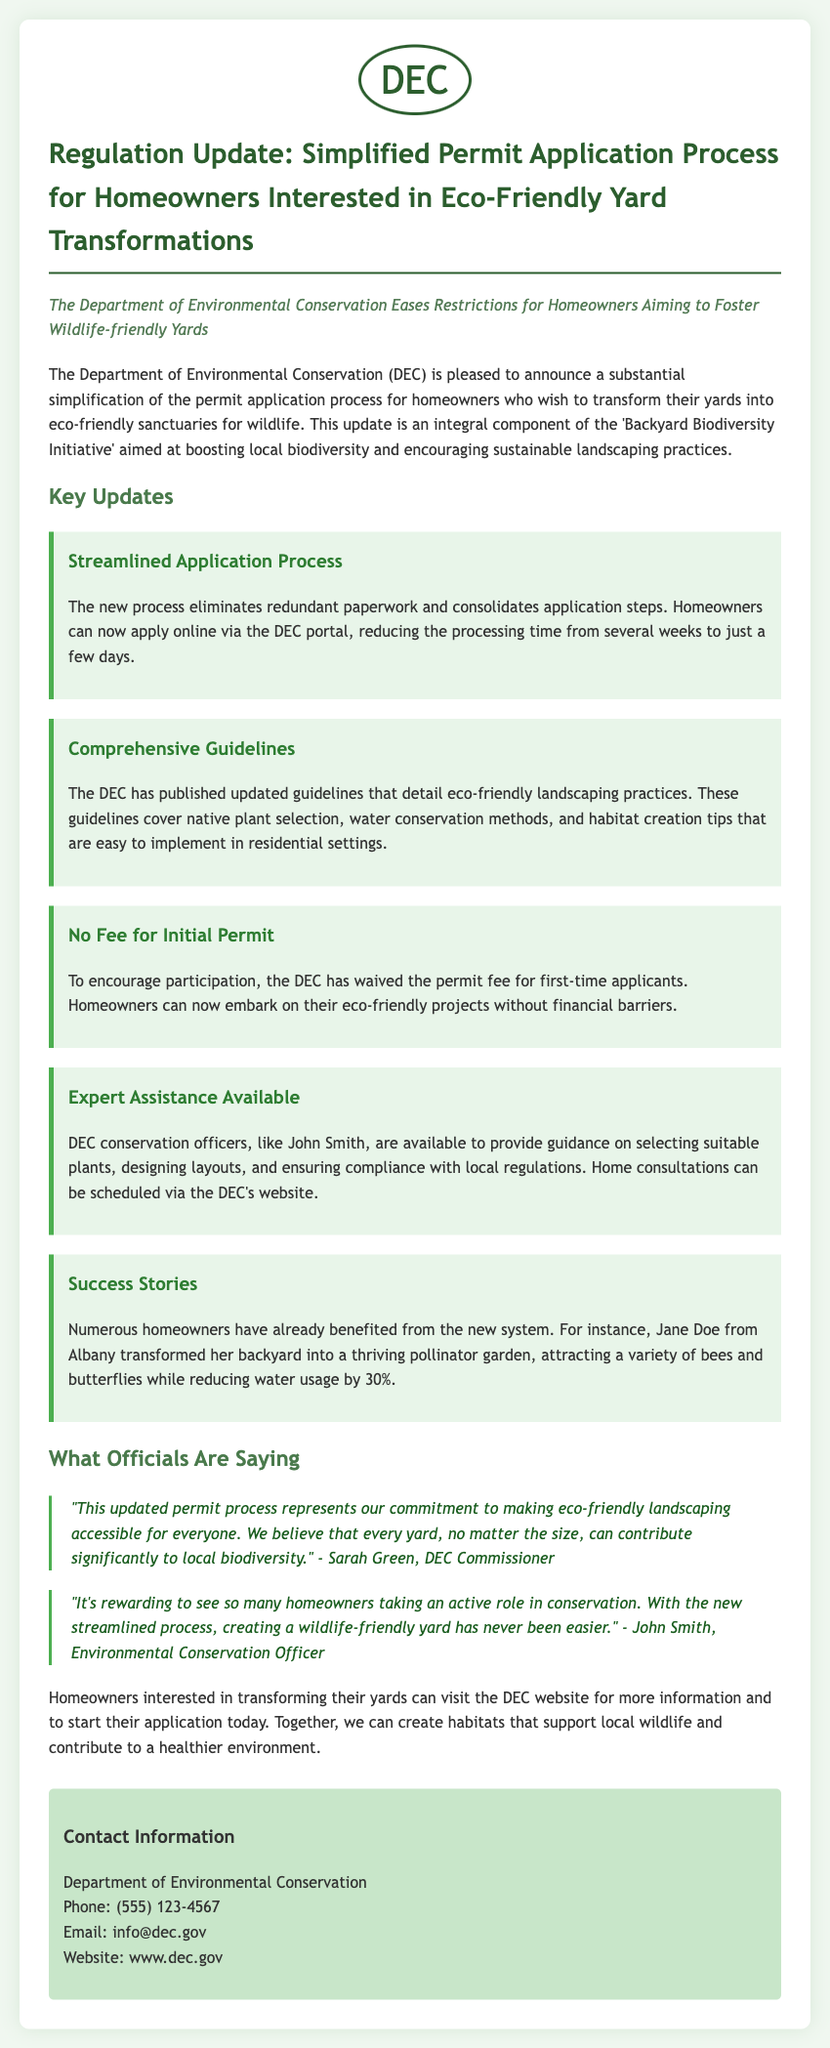What is the title of the press release? The title is the main heading that conveys the primary message of the document.
Answer: Regulation Update: Simplified Permit Application Process for Homeowners Interested in Eco-Friendly Yard Transformations Who published the updated guidelines? The updated guidelines were released by an organization tasked with environmental conservation.
Answer: DEC What initiative is mentioned in the press release? The initiative focuses on promoting biodiversity through easier processes for homeowners.
Answer: Backyard Biodiversity Initiative What is the new processing time for permit applications? The processing time is a key aspect of the updated application process, which was previously longer.
Answer: a few days How much is the permit fee for first-time applicants? The fee amount has been changed to encourage participation among new applicants.
Answer: No Fee Who can provide guidance to homeowners on landscaping? The role of guidance is essential for homeowners looking to comply with new regulations.
Answer: DEC conservation officers What type of garden did Jane Doe create? The example of Jane Doe highlights a successful transformation project.
Answer: pollinator garden What is the contact email for the Department of Environmental Conservation? The email address allows homeowners to seek further information or assistance.
Answer: info@dec.gov What did Sarah Green say about the updated permit process? The statement reflects the organization's commitment to making eco-friendly practices easier.
Answer: eco-friendly landscaping accessible for everyone 